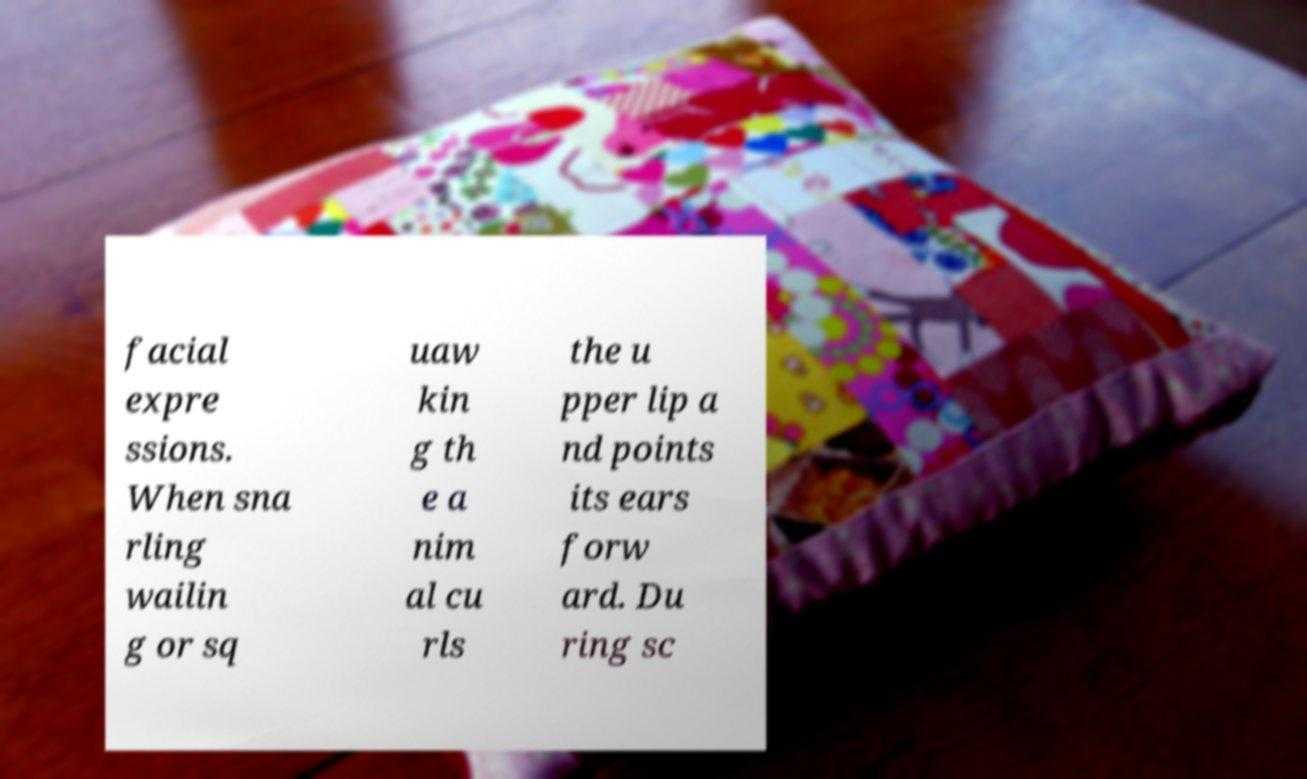What messages or text are displayed in this image? I need them in a readable, typed format. facial expre ssions. When sna rling wailin g or sq uaw kin g th e a nim al cu rls the u pper lip a nd points its ears forw ard. Du ring sc 